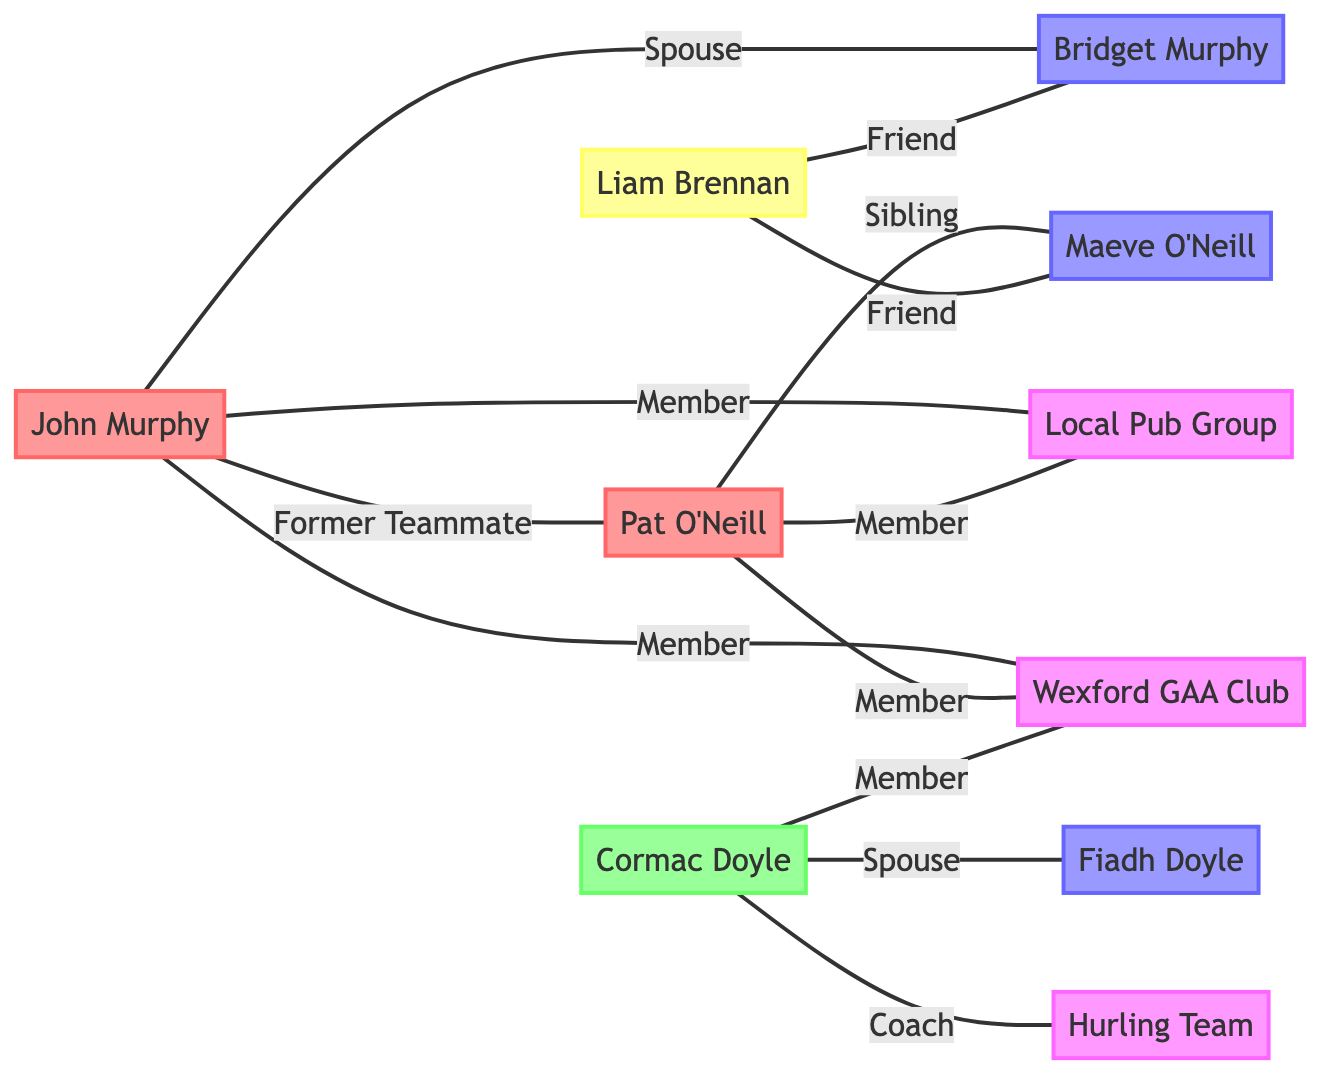What is the role of John Murphy? In the diagram, John Murphy's node is labeled "Former Player," which indicates his role within the social connections depicted.
Answer: Former Player How many nodes are in the diagram? The diagram includes 10 distinct nodes representing various people and social groups. Counting each node listed in the “nodes” section confirms this.
Answer: 10 What relationship exists between John Murphy and Bridget Murphy? The edge connecting John Murphy to Bridget Murphy is labeled "Spouse," indicating the type of relationship they share.
Answer: Spouse Who are the friends of Liam Brennan? By examining the edges connected to Liam Brennan, we see that he has two edges leading to Bridget Murphy and Maeve O'Neill, both labeled "Friend."
Answer: Bridget Murphy, Maeve O'Neill Which social group do both John Murphy and Pat O'Neill belong to? Both John Murphy and Pat O'Neill are connected to the "Local Pub Group" and "Wexford GAA Club," making them members of these social groups.
Answer: Local Pub Group, Wexford GAA Club What is the role of Cormac Doyle? Cormac Doyle's node is designated as "Coach," indicating his specific role in the context of the diagram.
Answer: Coach How many social groups are represented in the diagram? The diagram displays four unique social groups: "Local Pub Group," "Wexford GAA Club," "Hurling Team," and one that is not associated as a unique entity but connects team members together.
Answer: 4 Which family member is connected to Cormac Doyle? The edge between Cormac Doyle and Fiadh Doyle is labeled "Spouse," indicating that Fiadh Doyle is a family member connected to him.
Answer: Fiadh Doyle What type of connection does Pat O'Neill have with Maeve O'Neill? The edge connecting Pat O'Neill to Maeve O'Neill is labeled "Sibling," demonstrating their familial connection in the diagram.
Answer: Sibling 